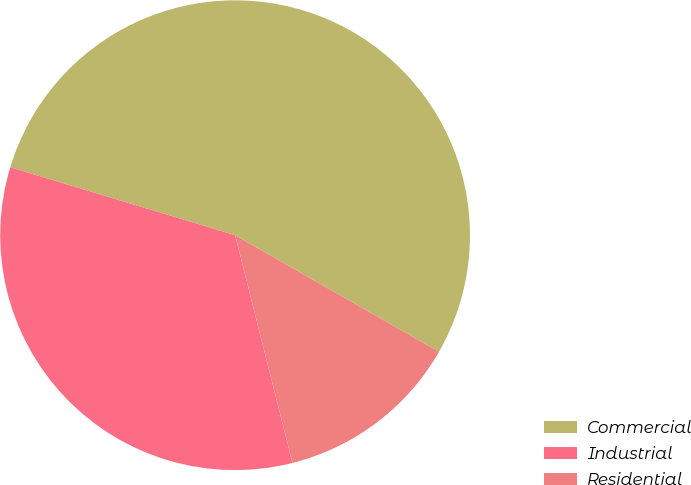Convert chart. <chart><loc_0><loc_0><loc_500><loc_500><pie_chart><fcel>Commercial<fcel>Industrial<fcel>Residential<nl><fcel>53.6%<fcel>33.6%<fcel>12.8%<nl></chart> 